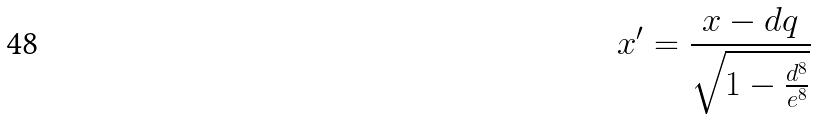<formula> <loc_0><loc_0><loc_500><loc_500>x ^ { \prime } = \frac { x - d q } { \sqrt { 1 - \frac { d ^ { 8 } } { e ^ { 8 } } } }</formula> 